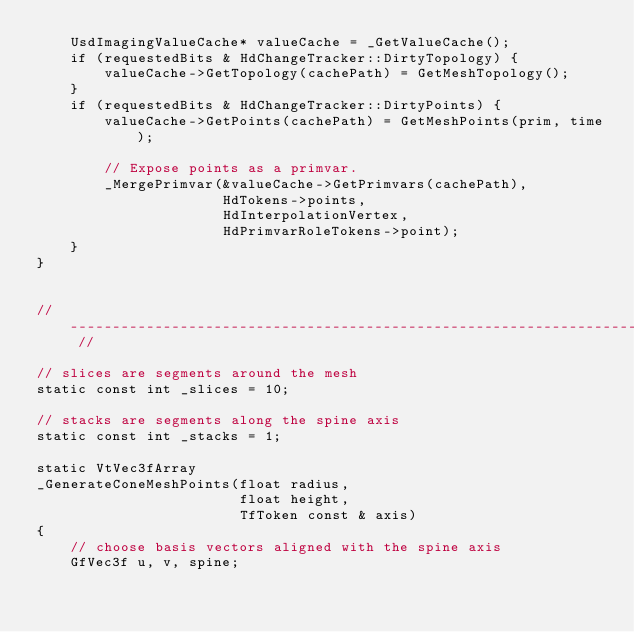<code> <loc_0><loc_0><loc_500><loc_500><_C++_>    UsdImagingValueCache* valueCache = _GetValueCache();
    if (requestedBits & HdChangeTracker::DirtyTopology) {
        valueCache->GetTopology(cachePath) = GetMeshTopology();
    }
    if (requestedBits & HdChangeTracker::DirtyPoints) {
        valueCache->GetPoints(cachePath) = GetMeshPoints(prim, time);

        // Expose points as a primvar.
        _MergePrimvar(&valueCache->GetPrimvars(cachePath),
                      HdTokens->points,
                      HdInterpolationVertex,
                      HdPrimvarRoleTokens->point);
    }
}


// -------------------------------------------------------------------------- //

// slices are segments around the mesh
static const int _slices = 10;

// stacks are segments along the spine axis
static const int _stacks = 1;

static VtVec3fArray
_GenerateConeMeshPoints(float radius,
                        float height,
                        TfToken const & axis)
{
    // choose basis vectors aligned with the spine axis
    GfVec3f u, v, spine;</code> 